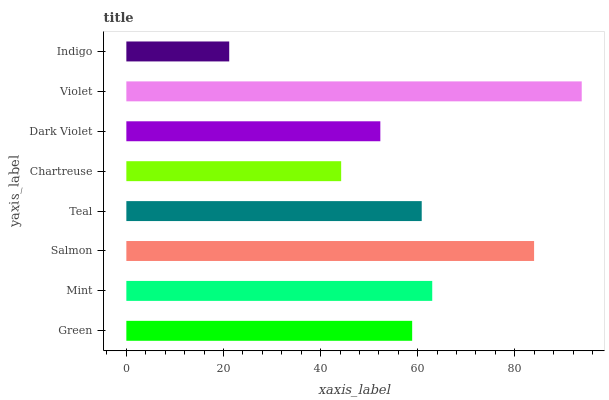Is Indigo the minimum?
Answer yes or no. Yes. Is Violet the maximum?
Answer yes or no. Yes. Is Mint the minimum?
Answer yes or no. No. Is Mint the maximum?
Answer yes or no. No. Is Mint greater than Green?
Answer yes or no. Yes. Is Green less than Mint?
Answer yes or no. Yes. Is Green greater than Mint?
Answer yes or no. No. Is Mint less than Green?
Answer yes or no. No. Is Teal the high median?
Answer yes or no. Yes. Is Green the low median?
Answer yes or no. Yes. Is Mint the high median?
Answer yes or no. No. Is Violet the low median?
Answer yes or no. No. 